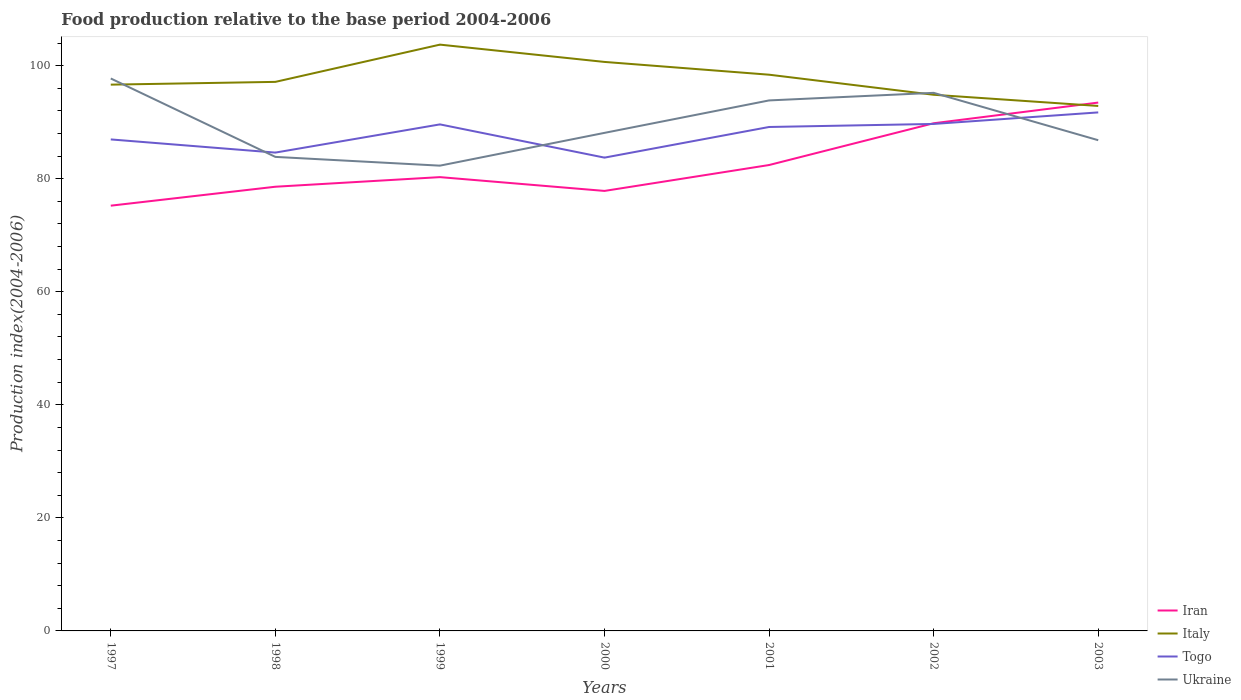How many different coloured lines are there?
Offer a terse response. 4. Does the line corresponding to Italy intersect with the line corresponding to Togo?
Offer a very short reply. No. Across all years, what is the maximum food production index in Ukraine?
Your response must be concise. 82.31. In which year was the food production index in Iran maximum?
Give a very brief answer. 1997. What is the total food production index in Togo in the graph?
Give a very brief answer. -5.42. What is the difference between the highest and the second highest food production index in Italy?
Offer a very short reply. 10.85. How many lines are there?
Keep it short and to the point. 4. How many years are there in the graph?
Your answer should be very brief. 7. What is the difference between two consecutive major ticks on the Y-axis?
Offer a terse response. 20. Does the graph contain grids?
Give a very brief answer. No. Where does the legend appear in the graph?
Keep it short and to the point. Bottom right. What is the title of the graph?
Your answer should be compact. Food production relative to the base period 2004-2006. Does "Central Europe" appear as one of the legend labels in the graph?
Make the answer very short. No. What is the label or title of the X-axis?
Provide a succinct answer. Years. What is the label or title of the Y-axis?
Offer a terse response. Production index(2004-2006). What is the Production index(2004-2006) of Iran in 1997?
Keep it short and to the point. 75.23. What is the Production index(2004-2006) in Italy in 1997?
Provide a succinct answer. 96.64. What is the Production index(2004-2006) of Togo in 1997?
Offer a very short reply. 86.95. What is the Production index(2004-2006) in Ukraine in 1997?
Your answer should be compact. 97.73. What is the Production index(2004-2006) of Iran in 1998?
Offer a terse response. 78.58. What is the Production index(2004-2006) of Italy in 1998?
Provide a succinct answer. 97.13. What is the Production index(2004-2006) in Togo in 1998?
Your response must be concise. 84.62. What is the Production index(2004-2006) of Ukraine in 1998?
Your answer should be very brief. 83.86. What is the Production index(2004-2006) in Iran in 1999?
Provide a short and direct response. 80.28. What is the Production index(2004-2006) in Italy in 1999?
Make the answer very short. 103.72. What is the Production index(2004-2006) in Togo in 1999?
Make the answer very short. 89.61. What is the Production index(2004-2006) in Ukraine in 1999?
Your response must be concise. 82.31. What is the Production index(2004-2006) in Iran in 2000?
Keep it short and to the point. 77.84. What is the Production index(2004-2006) of Italy in 2000?
Give a very brief answer. 100.66. What is the Production index(2004-2006) in Togo in 2000?
Keep it short and to the point. 83.73. What is the Production index(2004-2006) of Ukraine in 2000?
Give a very brief answer. 88.11. What is the Production index(2004-2006) in Iran in 2001?
Provide a succinct answer. 82.42. What is the Production index(2004-2006) in Italy in 2001?
Keep it short and to the point. 98.4. What is the Production index(2004-2006) of Togo in 2001?
Keep it short and to the point. 89.15. What is the Production index(2004-2006) of Ukraine in 2001?
Make the answer very short. 93.85. What is the Production index(2004-2006) of Iran in 2002?
Your answer should be compact. 89.81. What is the Production index(2004-2006) of Italy in 2002?
Offer a terse response. 94.85. What is the Production index(2004-2006) of Togo in 2002?
Your answer should be very brief. 89.69. What is the Production index(2004-2006) of Ukraine in 2002?
Provide a succinct answer. 95.19. What is the Production index(2004-2006) of Iran in 2003?
Make the answer very short. 93.47. What is the Production index(2004-2006) of Italy in 2003?
Make the answer very short. 92.87. What is the Production index(2004-2006) of Togo in 2003?
Offer a very short reply. 91.73. What is the Production index(2004-2006) in Ukraine in 2003?
Offer a very short reply. 86.81. Across all years, what is the maximum Production index(2004-2006) in Iran?
Give a very brief answer. 93.47. Across all years, what is the maximum Production index(2004-2006) of Italy?
Offer a very short reply. 103.72. Across all years, what is the maximum Production index(2004-2006) in Togo?
Your answer should be compact. 91.73. Across all years, what is the maximum Production index(2004-2006) in Ukraine?
Provide a succinct answer. 97.73. Across all years, what is the minimum Production index(2004-2006) in Iran?
Your answer should be compact. 75.23. Across all years, what is the minimum Production index(2004-2006) of Italy?
Ensure brevity in your answer.  92.87. Across all years, what is the minimum Production index(2004-2006) in Togo?
Give a very brief answer. 83.73. Across all years, what is the minimum Production index(2004-2006) of Ukraine?
Keep it short and to the point. 82.31. What is the total Production index(2004-2006) of Iran in the graph?
Your response must be concise. 577.63. What is the total Production index(2004-2006) in Italy in the graph?
Provide a short and direct response. 684.27. What is the total Production index(2004-2006) in Togo in the graph?
Offer a terse response. 615.48. What is the total Production index(2004-2006) of Ukraine in the graph?
Give a very brief answer. 627.86. What is the difference between the Production index(2004-2006) in Iran in 1997 and that in 1998?
Provide a short and direct response. -3.35. What is the difference between the Production index(2004-2006) in Italy in 1997 and that in 1998?
Your response must be concise. -0.49. What is the difference between the Production index(2004-2006) in Togo in 1997 and that in 1998?
Ensure brevity in your answer.  2.33. What is the difference between the Production index(2004-2006) in Ukraine in 1997 and that in 1998?
Keep it short and to the point. 13.87. What is the difference between the Production index(2004-2006) in Iran in 1997 and that in 1999?
Ensure brevity in your answer.  -5.05. What is the difference between the Production index(2004-2006) in Italy in 1997 and that in 1999?
Provide a succinct answer. -7.08. What is the difference between the Production index(2004-2006) of Togo in 1997 and that in 1999?
Offer a terse response. -2.66. What is the difference between the Production index(2004-2006) in Ukraine in 1997 and that in 1999?
Provide a short and direct response. 15.42. What is the difference between the Production index(2004-2006) in Iran in 1997 and that in 2000?
Your answer should be very brief. -2.61. What is the difference between the Production index(2004-2006) in Italy in 1997 and that in 2000?
Your answer should be very brief. -4.02. What is the difference between the Production index(2004-2006) of Togo in 1997 and that in 2000?
Offer a terse response. 3.22. What is the difference between the Production index(2004-2006) in Ukraine in 1997 and that in 2000?
Offer a terse response. 9.62. What is the difference between the Production index(2004-2006) in Iran in 1997 and that in 2001?
Make the answer very short. -7.19. What is the difference between the Production index(2004-2006) of Italy in 1997 and that in 2001?
Provide a short and direct response. -1.76. What is the difference between the Production index(2004-2006) of Ukraine in 1997 and that in 2001?
Offer a very short reply. 3.88. What is the difference between the Production index(2004-2006) of Iran in 1997 and that in 2002?
Make the answer very short. -14.58. What is the difference between the Production index(2004-2006) of Italy in 1997 and that in 2002?
Your response must be concise. 1.79. What is the difference between the Production index(2004-2006) in Togo in 1997 and that in 2002?
Offer a terse response. -2.74. What is the difference between the Production index(2004-2006) in Ukraine in 1997 and that in 2002?
Make the answer very short. 2.54. What is the difference between the Production index(2004-2006) of Iran in 1997 and that in 2003?
Make the answer very short. -18.24. What is the difference between the Production index(2004-2006) in Italy in 1997 and that in 2003?
Give a very brief answer. 3.77. What is the difference between the Production index(2004-2006) of Togo in 1997 and that in 2003?
Ensure brevity in your answer.  -4.78. What is the difference between the Production index(2004-2006) of Ukraine in 1997 and that in 2003?
Offer a very short reply. 10.92. What is the difference between the Production index(2004-2006) in Italy in 1998 and that in 1999?
Your response must be concise. -6.59. What is the difference between the Production index(2004-2006) of Togo in 1998 and that in 1999?
Provide a succinct answer. -4.99. What is the difference between the Production index(2004-2006) of Ukraine in 1998 and that in 1999?
Ensure brevity in your answer.  1.55. What is the difference between the Production index(2004-2006) in Iran in 1998 and that in 2000?
Provide a succinct answer. 0.74. What is the difference between the Production index(2004-2006) in Italy in 1998 and that in 2000?
Your answer should be compact. -3.53. What is the difference between the Production index(2004-2006) of Togo in 1998 and that in 2000?
Provide a short and direct response. 0.89. What is the difference between the Production index(2004-2006) in Ukraine in 1998 and that in 2000?
Your answer should be compact. -4.25. What is the difference between the Production index(2004-2006) of Iran in 1998 and that in 2001?
Provide a succinct answer. -3.84. What is the difference between the Production index(2004-2006) in Italy in 1998 and that in 2001?
Offer a very short reply. -1.27. What is the difference between the Production index(2004-2006) of Togo in 1998 and that in 2001?
Give a very brief answer. -4.53. What is the difference between the Production index(2004-2006) in Ukraine in 1998 and that in 2001?
Offer a terse response. -9.99. What is the difference between the Production index(2004-2006) of Iran in 1998 and that in 2002?
Provide a short and direct response. -11.23. What is the difference between the Production index(2004-2006) of Italy in 1998 and that in 2002?
Make the answer very short. 2.28. What is the difference between the Production index(2004-2006) in Togo in 1998 and that in 2002?
Ensure brevity in your answer.  -5.07. What is the difference between the Production index(2004-2006) of Ukraine in 1998 and that in 2002?
Give a very brief answer. -11.33. What is the difference between the Production index(2004-2006) of Iran in 1998 and that in 2003?
Provide a succinct answer. -14.89. What is the difference between the Production index(2004-2006) in Italy in 1998 and that in 2003?
Your answer should be compact. 4.26. What is the difference between the Production index(2004-2006) in Togo in 1998 and that in 2003?
Your answer should be very brief. -7.11. What is the difference between the Production index(2004-2006) in Ukraine in 1998 and that in 2003?
Your answer should be compact. -2.95. What is the difference between the Production index(2004-2006) of Iran in 1999 and that in 2000?
Your response must be concise. 2.44. What is the difference between the Production index(2004-2006) of Italy in 1999 and that in 2000?
Offer a terse response. 3.06. What is the difference between the Production index(2004-2006) in Togo in 1999 and that in 2000?
Provide a succinct answer. 5.88. What is the difference between the Production index(2004-2006) in Ukraine in 1999 and that in 2000?
Provide a succinct answer. -5.8. What is the difference between the Production index(2004-2006) of Iran in 1999 and that in 2001?
Your response must be concise. -2.14. What is the difference between the Production index(2004-2006) in Italy in 1999 and that in 2001?
Offer a terse response. 5.32. What is the difference between the Production index(2004-2006) in Togo in 1999 and that in 2001?
Offer a terse response. 0.46. What is the difference between the Production index(2004-2006) of Ukraine in 1999 and that in 2001?
Your answer should be very brief. -11.54. What is the difference between the Production index(2004-2006) in Iran in 1999 and that in 2002?
Your answer should be very brief. -9.53. What is the difference between the Production index(2004-2006) of Italy in 1999 and that in 2002?
Your response must be concise. 8.87. What is the difference between the Production index(2004-2006) of Togo in 1999 and that in 2002?
Offer a terse response. -0.08. What is the difference between the Production index(2004-2006) in Ukraine in 1999 and that in 2002?
Provide a short and direct response. -12.88. What is the difference between the Production index(2004-2006) in Iran in 1999 and that in 2003?
Make the answer very short. -13.19. What is the difference between the Production index(2004-2006) of Italy in 1999 and that in 2003?
Your response must be concise. 10.85. What is the difference between the Production index(2004-2006) in Togo in 1999 and that in 2003?
Give a very brief answer. -2.12. What is the difference between the Production index(2004-2006) in Ukraine in 1999 and that in 2003?
Offer a terse response. -4.5. What is the difference between the Production index(2004-2006) in Iran in 2000 and that in 2001?
Your answer should be very brief. -4.58. What is the difference between the Production index(2004-2006) of Italy in 2000 and that in 2001?
Provide a short and direct response. 2.26. What is the difference between the Production index(2004-2006) in Togo in 2000 and that in 2001?
Your answer should be compact. -5.42. What is the difference between the Production index(2004-2006) of Ukraine in 2000 and that in 2001?
Your answer should be compact. -5.74. What is the difference between the Production index(2004-2006) in Iran in 2000 and that in 2002?
Give a very brief answer. -11.97. What is the difference between the Production index(2004-2006) in Italy in 2000 and that in 2002?
Your answer should be very brief. 5.81. What is the difference between the Production index(2004-2006) of Togo in 2000 and that in 2002?
Your response must be concise. -5.96. What is the difference between the Production index(2004-2006) in Ukraine in 2000 and that in 2002?
Make the answer very short. -7.08. What is the difference between the Production index(2004-2006) of Iran in 2000 and that in 2003?
Ensure brevity in your answer.  -15.63. What is the difference between the Production index(2004-2006) in Italy in 2000 and that in 2003?
Offer a terse response. 7.79. What is the difference between the Production index(2004-2006) of Togo in 2000 and that in 2003?
Your answer should be very brief. -8. What is the difference between the Production index(2004-2006) in Ukraine in 2000 and that in 2003?
Provide a short and direct response. 1.3. What is the difference between the Production index(2004-2006) of Iran in 2001 and that in 2002?
Provide a short and direct response. -7.39. What is the difference between the Production index(2004-2006) of Italy in 2001 and that in 2002?
Your response must be concise. 3.55. What is the difference between the Production index(2004-2006) of Togo in 2001 and that in 2002?
Ensure brevity in your answer.  -0.54. What is the difference between the Production index(2004-2006) of Ukraine in 2001 and that in 2002?
Your answer should be very brief. -1.34. What is the difference between the Production index(2004-2006) in Iran in 2001 and that in 2003?
Offer a terse response. -11.05. What is the difference between the Production index(2004-2006) in Italy in 2001 and that in 2003?
Give a very brief answer. 5.53. What is the difference between the Production index(2004-2006) in Togo in 2001 and that in 2003?
Provide a succinct answer. -2.58. What is the difference between the Production index(2004-2006) in Ukraine in 2001 and that in 2003?
Give a very brief answer. 7.04. What is the difference between the Production index(2004-2006) in Iran in 2002 and that in 2003?
Provide a short and direct response. -3.66. What is the difference between the Production index(2004-2006) in Italy in 2002 and that in 2003?
Keep it short and to the point. 1.98. What is the difference between the Production index(2004-2006) in Togo in 2002 and that in 2003?
Make the answer very short. -2.04. What is the difference between the Production index(2004-2006) of Ukraine in 2002 and that in 2003?
Ensure brevity in your answer.  8.38. What is the difference between the Production index(2004-2006) in Iran in 1997 and the Production index(2004-2006) in Italy in 1998?
Your response must be concise. -21.9. What is the difference between the Production index(2004-2006) in Iran in 1997 and the Production index(2004-2006) in Togo in 1998?
Keep it short and to the point. -9.39. What is the difference between the Production index(2004-2006) in Iran in 1997 and the Production index(2004-2006) in Ukraine in 1998?
Provide a succinct answer. -8.63. What is the difference between the Production index(2004-2006) of Italy in 1997 and the Production index(2004-2006) of Togo in 1998?
Provide a short and direct response. 12.02. What is the difference between the Production index(2004-2006) in Italy in 1997 and the Production index(2004-2006) in Ukraine in 1998?
Your response must be concise. 12.78. What is the difference between the Production index(2004-2006) in Togo in 1997 and the Production index(2004-2006) in Ukraine in 1998?
Your answer should be compact. 3.09. What is the difference between the Production index(2004-2006) in Iran in 1997 and the Production index(2004-2006) in Italy in 1999?
Provide a succinct answer. -28.49. What is the difference between the Production index(2004-2006) in Iran in 1997 and the Production index(2004-2006) in Togo in 1999?
Your response must be concise. -14.38. What is the difference between the Production index(2004-2006) in Iran in 1997 and the Production index(2004-2006) in Ukraine in 1999?
Provide a succinct answer. -7.08. What is the difference between the Production index(2004-2006) in Italy in 1997 and the Production index(2004-2006) in Togo in 1999?
Offer a terse response. 7.03. What is the difference between the Production index(2004-2006) in Italy in 1997 and the Production index(2004-2006) in Ukraine in 1999?
Your response must be concise. 14.33. What is the difference between the Production index(2004-2006) of Togo in 1997 and the Production index(2004-2006) of Ukraine in 1999?
Keep it short and to the point. 4.64. What is the difference between the Production index(2004-2006) of Iran in 1997 and the Production index(2004-2006) of Italy in 2000?
Offer a terse response. -25.43. What is the difference between the Production index(2004-2006) of Iran in 1997 and the Production index(2004-2006) of Togo in 2000?
Ensure brevity in your answer.  -8.5. What is the difference between the Production index(2004-2006) in Iran in 1997 and the Production index(2004-2006) in Ukraine in 2000?
Offer a very short reply. -12.88. What is the difference between the Production index(2004-2006) of Italy in 1997 and the Production index(2004-2006) of Togo in 2000?
Give a very brief answer. 12.91. What is the difference between the Production index(2004-2006) in Italy in 1997 and the Production index(2004-2006) in Ukraine in 2000?
Your answer should be compact. 8.53. What is the difference between the Production index(2004-2006) in Togo in 1997 and the Production index(2004-2006) in Ukraine in 2000?
Offer a terse response. -1.16. What is the difference between the Production index(2004-2006) in Iran in 1997 and the Production index(2004-2006) in Italy in 2001?
Provide a succinct answer. -23.17. What is the difference between the Production index(2004-2006) of Iran in 1997 and the Production index(2004-2006) of Togo in 2001?
Make the answer very short. -13.92. What is the difference between the Production index(2004-2006) in Iran in 1997 and the Production index(2004-2006) in Ukraine in 2001?
Your response must be concise. -18.62. What is the difference between the Production index(2004-2006) in Italy in 1997 and the Production index(2004-2006) in Togo in 2001?
Give a very brief answer. 7.49. What is the difference between the Production index(2004-2006) of Italy in 1997 and the Production index(2004-2006) of Ukraine in 2001?
Your response must be concise. 2.79. What is the difference between the Production index(2004-2006) of Iran in 1997 and the Production index(2004-2006) of Italy in 2002?
Your answer should be very brief. -19.62. What is the difference between the Production index(2004-2006) of Iran in 1997 and the Production index(2004-2006) of Togo in 2002?
Make the answer very short. -14.46. What is the difference between the Production index(2004-2006) in Iran in 1997 and the Production index(2004-2006) in Ukraine in 2002?
Make the answer very short. -19.96. What is the difference between the Production index(2004-2006) of Italy in 1997 and the Production index(2004-2006) of Togo in 2002?
Your answer should be compact. 6.95. What is the difference between the Production index(2004-2006) of Italy in 1997 and the Production index(2004-2006) of Ukraine in 2002?
Your answer should be very brief. 1.45. What is the difference between the Production index(2004-2006) of Togo in 1997 and the Production index(2004-2006) of Ukraine in 2002?
Your answer should be compact. -8.24. What is the difference between the Production index(2004-2006) in Iran in 1997 and the Production index(2004-2006) in Italy in 2003?
Give a very brief answer. -17.64. What is the difference between the Production index(2004-2006) in Iran in 1997 and the Production index(2004-2006) in Togo in 2003?
Provide a succinct answer. -16.5. What is the difference between the Production index(2004-2006) of Iran in 1997 and the Production index(2004-2006) of Ukraine in 2003?
Offer a terse response. -11.58. What is the difference between the Production index(2004-2006) of Italy in 1997 and the Production index(2004-2006) of Togo in 2003?
Your response must be concise. 4.91. What is the difference between the Production index(2004-2006) of Italy in 1997 and the Production index(2004-2006) of Ukraine in 2003?
Your response must be concise. 9.83. What is the difference between the Production index(2004-2006) in Togo in 1997 and the Production index(2004-2006) in Ukraine in 2003?
Provide a short and direct response. 0.14. What is the difference between the Production index(2004-2006) in Iran in 1998 and the Production index(2004-2006) in Italy in 1999?
Give a very brief answer. -25.14. What is the difference between the Production index(2004-2006) of Iran in 1998 and the Production index(2004-2006) of Togo in 1999?
Provide a short and direct response. -11.03. What is the difference between the Production index(2004-2006) of Iran in 1998 and the Production index(2004-2006) of Ukraine in 1999?
Offer a terse response. -3.73. What is the difference between the Production index(2004-2006) in Italy in 1998 and the Production index(2004-2006) in Togo in 1999?
Give a very brief answer. 7.52. What is the difference between the Production index(2004-2006) of Italy in 1998 and the Production index(2004-2006) of Ukraine in 1999?
Your answer should be compact. 14.82. What is the difference between the Production index(2004-2006) of Togo in 1998 and the Production index(2004-2006) of Ukraine in 1999?
Provide a succinct answer. 2.31. What is the difference between the Production index(2004-2006) of Iran in 1998 and the Production index(2004-2006) of Italy in 2000?
Keep it short and to the point. -22.08. What is the difference between the Production index(2004-2006) in Iran in 1998 and the Production index(2004-2006) in Togo in 2000?
Make the answer very short. -5.15. What is the difference between the Production index(2004-2006) in Iran in 1998 and the Production index(2004-2006) in Ukraine in 2000?
Your response must be concise. -9.53. What is the difference between the Production index(2004-2006) of Italy in 1998 and the Production index(2004-2006) of Ukraine in 2000?
Provide a short and direct response. 9.02. What is the difference between the Production index(2004-2006) of Togo in 1998 and the Production index(2004-2006) of Ukraine in 2000?
Provide a short and direct response. -3.49. What is the difference between the Production index(2004-2006) of Iran in 1998 and the Production index(2004-2006) of Italy in 2001?
Give a very brief answer. -19.82. What is the difference between the Production index(2004-2006) in Iran in 1998 and the Production index(2004-2006) in Togo in 2001?
Your answer should be compact. -10.57. What is the difference between the Production index(2004-2006) of Iran in 1998 and the Production index(2004-2006) of Ukraine in 2001?
Ensure brevity in your answer.  -15.27. What is the difference between the Production index(2004-2006) in Italy in 1998 and the Production index(2004-2006) in Togo in 2001?
Make the answer very short. 7.98. What is the difference between the Production index(2004-2006) of Italy in 1998 and the Production index(2004-2006) of Ukraine in 2001?
Ensure brevity in your answer.  3.28. What is the difference between the Production index(2004-2006) in Togo in 1998 and the Production index(2004-2006) in Ukraine in 2001?
Your answer should be compact. -9.23. What is the difference between the Production index(2004-2006) of Iran in 1998 and the Production index(2004-2006) of Italy in 2002?
Keep it short and to the point. -16.27. What is the difference between the Production index(2004-2006) in Iran in 1998 and the Production index(2004-2006) in Togo in 2002?
Give a very brief answer. -11.11. What is the difference between the Production index(2004-2006) of Iran in 1998 and the Production index(2004-2006) of Ukraine in 2002?
Give a very brief answer. -16.61. What is the difference between the Production index(2004-2006) in Italy in 1998 and the Production index(2004-2006) in Togo in 2002?
Offer a terse response. 7.44. What is the difference between the Production index(2004-2006) of Italy in 1998 and the Production index(2004-2006) of Ukraine in 2002?
Offer a terse response. 1.94. What is the difference between the Production index(2004-2006) of Togo in 1998 and the Production index(2004-2006) of Ukraine in 2002?
Offer a terse response. -10.57. What is the difference between the Production index(2004-2006) in Iran in 1998 and the Production index(2004-2006) in Italy in 2003?
Offer a terse response. -14.29. What is the difference between the Production index(2004-2006) in Iran in 1998 and the Production index(2004-2006) in Togo in 2003?
Provide a short and direct response. -13.15. What is the difference between the Production index(2004-2006) of Iran in 1998 and the Production index(2004-2006) of Ukraine in 2003?
Your response must be concise. -8.23. What is the difference between the Production index(2004-2006) in Italy in 1998 and the Production index(2004-2006) in Ukraine in 2003?
Give a very brief answer. 10.32. What is the difference between the Production index(2004-2006) of Togo in 1998 and the Production index(2004-2006) of Ukraine in 2003?
Give a very brief answer. -2.19. What is the difference between the Production index(2004-2006) of Iran in 1999 and the Production index(2004-2006) of Italy in 2000?
Ensure brevity in your answer.  -20.38. What is the difference between the Production index(2004-2006) of Iran in 1999 and the Production index(2004-2006) of Togo in 2000?
Provide a short and direct response. -3.45. What is the difference between the Production index(2004-2006) of Iran in 1999 and the Production index(2004-2006) of Ukraine in 2000?
Your response must be concise. -7.83. What is the difference between the Production index(2004-2006) of Italy in 1999 and the Production index(2004-2006) of Togo in 2000?
Provide a short and direct response. 19.99. What is the difference between the Production index(2004-2006) in Italy in 1999 and the Production index(2004-2006) in Ukraine in 2000?
Ensure brevity in your answer.  15.61. What is the difference between the Production index(2004-2006) in Togo in 1999 and the Production index(2004-2006) in Ukraine in 2000?
Give a very brief answer. 1.5. What is the difference between the Production index(2004-2006) of Iran in 1999 and the Production index(2004-2006) of Italy in 2001?
Keep it short and to the point. -18.12. What is the difference between the Production index(2004-2006) of Iran in 1999 and the Production index(2004-2006) of Togo in 2001?
Ensure brevity in your answer.  -8.87. What is the difference between the Production index(2004-2006) of Iran in 1999 and the Production index(2004-2006) of Ukraine in 2001?
Provide a short and direct response. -13.57. What is the difference between the Production index(2004-2006) in Italy in 1999 and the Production index(2004-2006) in Togo in 2001?
Provide a short and direct response. 14.57. What is the difference between the Production index(2004-2006) in Italy in 1999 and the Production index(2004-2006) in Ukraine in 2001?
Provide a short and direct response. 9.87. What is the difference between the Production index(2004-2006) in Togo in 1999 and the Production index(2004-2006) in Ukraine in 2001?
Offer a terse response. -4.24. What is the difference between the Production index(2004-2006) in Iran in 1999 and the Production index(2004-2006) in Italy in 2002?
Your answer should be very brief. -14.57. What is the difference between the Production index(2004-2006) of Iran in 1999 and the Production index(2004-2006) of Togo in 2002?
Make the answer very short. -9.41. What is the difference between the Production index(2004-2006) in Iran in 1999 and the Production index(2004-2006) in Ukraine in 2002?
Offer a very short reply. -14.91. What is the difference between the Production index(2004-2006) of Italy in 1999 and the Production index(2004-2006) of Togo in 2002?
Give a very brief answer. 14.03. What is the difference between the Production index(2004-2006) in Italy in 1999 and the Production index(2004-2006) in Ukraine in 2002?
Keep it short and to the point. 8.53. What is the difference between the Production index(2004-2006) in Togo in 1999 and the Production index(2004-2006) in Ukraine in 2002?
Provide a succinct answer. -5.58. What is the difference between the Production index(2004-2006) of Iran in 1999 and the Production index(2004-2006) of Italy in 2003?
Provide a succinct answer. -12.59. What is the difference between the Production index(2004-2006) of Iran in 1999 and the Production index(2004-2006) of Togo in 2003?
Give a very brief answer. -11.45. What is the difference between the Production index(2004-2006) of Iran in 1999 and the Production index(2004-2006) of Ukraine in 2003?
Make the answer very short. -6.53. What is the difference between the Production index(2004-2006) of Italy in 1999 and the Production index(2004-2006) of Togo in 2003?
Your answer should be compact. 11.99. What is the difference between the Production index(2004-2006) in Italy in 1999 and the Production index(2004-2006) in Ukraine in 2003?
Offer a terse response. 16.91. What is the difference between the Production index(2004-2006) in Iran in 2000 and the Production index(2004-2006) in Italy in 2001?
Your answer should be very brief. -20.56. What is the difference between the Production index(2004-2006) in Iran in 2000 and the Production index(2004-2006) in Togo in 2001?
Make the answer very short. -11.31. What is the difference between the Production index(2004-2006) in Iran in 2000 and the Production index(2004-2006) in Ukraine in 2001?
Your response must be concise. -16.01. What is the difference between the Production index(2004-2006) of Italy in 2000 and the Production index(2004-2006) of Togo in 2001?
Ensure brevity in your answer.  11.51. What is the difference between the Production index(2004-2006) in Italy in 2000 and the Production index(2004-2006) in Ukraine in 2001?
Give a very brief answer. 6.81. What is the difference between the Production index(2004-2006) of Togo in 2000 and the Production index(2004-2006) of Ukraine in 2001?
Keep it short and to the point. -10.12. What is the difference between the Production index(2004-2006) in Iran in 2000 and the Production index(2004-2006) in Italy in 2002?
Give a very brief answer. -17.01. What is the difference between the Production index(2004-2006) in Iran in 2000 and the Production index(2004-2006) in Togo in 2002?
Provide a short and direct response. -11.85. What is the difference between the Production index(2004-2006) of Iran in 2000 and the Production index(2004-2006) of Ukraine in 2002?
Provide a short and direct response. -17.35. What is the difference between the Production index(2004-2006) in Italy in 2000 and the Production index(2004-2006) in Togo in 2002?
Give a very brief answer. 10.97. What is the difference between the Production index(2004-2006) of Italy in 2000 and the Production index(2004-2006) of Ukraine in 2002?
Offer a very short reply. 5.47. What is the difference between the Production index(2004-2006) of Togo in 2000 and the Production index(2004-2006) of Ukraine in 2002?
Offer a terse response. -11.46. What is the difference between the Production index(2004-2006) of Iran in 2000 and the Production index(2004-2006) of Italy in 2003?
Ensure brevity in your answer.  -15.03. What is the difference between the Production index(2004-2006) in Iran in 2000 and the Production index(2004-2006) in Togo in 2003?
Offer a very short reply. -13.89. What is the difference between the Production index(2004-2006) in Iran in 2000 and the Production index(2004-2006) in Ukraine in 2003?
Your answer should be compact. -8.97. What is the difference between the Production index(2004-2006) of Italy in 2000 and the Production index(2004-2006) of Togo in 2003?
Keep it short and to the point. 8.93. What is the difference between the Production index(2004-2006) in Italy in 2000 and the Production index(2004-2006) in Ukraine in 2003?
Make the answer very short. 13.85. What is the difference between the Production index(2004-2006) of Togo in 2000 and the Production index(2004-2006) of Ukraine in 2003?
Your response must be concise. -3.08. What is the difference between the Production index(2004-2006) in Iran in 2001 and the Production index(2004-2006) in Italy in 2002?
Give a very brief answer. -12.43. What is the difference between the Production index(2004-2006) of Iran in 2001 and the Production index(2004-2006) of Togo in 2002?
Offer a very short reply. -7.27. What is the difference between the Production index(2004-2006) in Iran in 2001 and the Production index(2004-2006) in Ukraine in 2002?
Provide a succinct answer. -12.77. What is the difference between the Production index(2004-2006) in Italy in 2001 and the Production index(2004-2006) in Togo in 2002?
Provide a short and direct response. 8.71. What is the difference between the Production index(2004-2006) in Italy in 2001 and the Production index(2004-2006) in Ukraine in 2002?
Provide a short and direct response. 3.21. What is the difference between the Production index(2004-2006) of Togo in 2001 and the Production index(2004-2006) of Ukraine in 2002?
Your answer should be very brief. -6.04. What is the difference between the Production index(2004-2006) in Iran in 2001 and the Production index(2004-2006) in Italy in 2003?
Your answer should be compact. -10.45. What is the difference between the Production index(2004-2006) of Iran in 2001 and the Production index(2004-2006) of Togo in 2003?
Offer a very short reply. -9.31. What is the difference between the Production index(2004-2006) of Iran in 2001 and the Production index(2004-2006) of Ukraine in 2003?
Keep it short and to the point. -4.39. What is the difference between the Production index(2004-2006) in Italy in 2001 and the Production index(2004-2006) in Togo in 2003?
Ensure brevity in your answer.  6.67. What is the difference between the Production index(2004-2006) in Italy in 2001 and the Production index(2004-2006) in Ukraine in 2003?
Your answer should be very brief. 11.59. What is the difference between the Production index(2004-2006) of Togo in 2001 and the Production index(2004-2006) of Ukraine in 2003?
Your response must be concise. 2.34. What is the difference between the Production index(2004-2006) of Iran in 2002 and the Production index(2004-2006) of Italy in 2003?
Your response must be concise. -3.06. What is the difference between the Production index(2004-2006) of Iran in 2002 and the Production index(2004-2006) of Togo in 2003?
Your response must be concise. -1.92. What is the difference between the Production index(2004-2006) of Iran in 2002 and the Production index(2004-2006) of Ukraine in 2003?
Keep it short and to the point. 3. What is the difference between the Production index(2004-2006) in Italy in 2002 and the Production index(2004-2006) in Togo in 2003?
Your answer should be very brief. 3.12. What is the difference between the Production index(2004-2006) in Italy in 2002 and the Production index(2004-2006) in Ukraine in 2003?
Provide a short and direct response. 8.04. What is the difference between the Production index(2004-2006) in Togo in 2002 and the Production index(2004-2006) in Ukraine in 2003?
Provide a short and direct response. 2.88. What is the average Production index(2004-2006) of Iran per year?
Provide a succinct answer. 82.52. What is the average Production index(2004-2006) of Italy per year?
Provide a short and direct response. 97.75. What is the average Production index(2004-2006) in Togo per year?
Your answer should be compact. 87.93. What is the average Production index(2004-2006) of Ukraine per year?
Offer a very short reply. 89.69. In the year 1997, what is the difference between the Production index(2004-2006) in Iran and Production index(2004-2006) in Italy?
Provide a succinct answer. -21.41. In the year 1997, what is the difference between the Production index(2004-2006) of Iran and Production index(2004-2006) of Togo?
Ensure brevity in your answer.  -11.72. In the year 1997, what is the difference between the Production index(2004-2006) in Iran and Production index(2004-2006) in Ukraine?
Your answer should be very brief. -22.5. In the year 1997, what is the difference between the Production index(2004-2006) of Italy and Production index(2004-2006) of Togo?
Make the answer very short. 9.69. In the year 1997, what is the difference between the Production index(2004-2006) of Italy and Production index(2004-2006) of Ukraine?
Keep it short and to the point. -1.09. In the year 1997, what is the difference between the Production index(2004-2006) of Togo and Production index(2004-2006) of Ukraine?
Your answer should be very brief. -10.78. In the year 1998, what is the difference between the Production index(2004-2006) in Iran and Production index(2004-2006) in Italy?
Ensure brevity in your answer.  -18.55. In the year 1998, what is the difference between the Production index(2004-2006) in Iran and Production index(2004-2006) in Togo?
Give a very brief answer. -6.04. In the year 1998, what is the difference between the Production index(2004-2006) of Iran and Production index(2004-2006) of Ukraine?
Offer a very short reply. -5.28. In the year 1998, what is the difference between the Production index(2004-2006) of Italy and Production index(2004-2006) of Togo?
Keep it short and to the point. 12.51. In the year 1998, what is the difference between the Production index(2004-2006) of Italy and Production index(2004-2006) of Ukraine?
Offer a very short reply. 13.27. In the year 1998, what is the difference between the Production index(2004-2006) of Togo and Production index(2004-2006) of Ukraine?
Keep it short and to the point. 0.76. In the year 1999, what is the difference between the Production index(2004-2006) in Iran and Production index(2004-2006) in Italy?
Give a very brief answer. -23.44. In the year 1999, what is the difference between the Production index(2004-2006) of Iran and Production index(2004-2006) of Togo?
Offer a terse response. -9.33. In the year 1999, what is the difference between the Production index(2004-2006) in Iran and Production index(2004-2006) in Ukraine?
Make the answer very short. -2.03. In the year 1999, what is the difference between the Production index(2004-2006) in Italy and Production index(2004-2006) in Togo?
Your response must be concise. 14.11. In the year 1999, what is the difference between the Production index(2004-2006) of Italy and Production index(2004-2006) of Ukraine?
Offer a terse response. 21.41. In the year 1999, what is the difference between the Production index(2004-2006) of Togo and Production index(2004-2006) of Ukraine?
Make the answer very short. 7.3. In the year 2000, what is the difference between the Production index(2004-2006) in Iran and Production index(2004-2006) in Italy?
Your answer should be compact. -22.82. In the year 2000, what is the difference between the Production index(2004-2006) in Iran and Production index(2004-2006) in Togo?
Offer a terse response. -5.89. In the year 2000, what is the difference between the Production index(2004-2006) of Iran and Production index(2004-2006) of Ukraine?
Provide a succinct answer. -10.27. In the year 2000, what is the difference between the Production index(2004-2006) in Italy and Production index(2004-2006) in Togo?
Offer a very short reply. 16.93. In the year 2000, what is the difference between the Production index(2004-2006) of Italy and Production index(2004-2006) of Ukraine?
Provide a succinct answer. 12.55. In the year 2000, what is the difference between the Production index(2004-2006) of Togo and Production index(2004-2006) of Ukraine?
Keep it short and to the point. -4.38. In the year 2001, what is the difference between the Production index(2004-2006) of Iran and Production index(2004-2006) of Italy?
Ensure brevity in your answer.  -15.98. In the year 2001, what is the difference between the Production index(2004-2006) in Iran and Production index(2004-2006) in Togo?
Your response must be concise. -6.73. In the year 2001, what is the difference between the Production index(2004-2006) of Iran and Production index(2004-2006) of Ukraine?
Your answer should be very brief. -11.43. In the year 2001, what is the difference between the Production index(2004-2006) in Italy and Production index(2004-2006) in Togo?
Your answer should be very brief. 9.25. In the year 2001, what is the difference between the Production index(2004-2006) of Italy and Production index(2004-2006) of Ukraine?
Give a very brief answer. 4.55. In the year 2002, what is the difference between the Production index(2004-2006) in Iran and Production index(2004-2006) in Italy?
Your response must be concise. -5.04. In the year 2002, what is the difference between the Production index(2004-2006) in Iran and Production index(2004-2006) in Togo?
Provide a succinct answer. 0.12. In the year 2002, what is the difference between the Production index(2004-2006) of Iran and Production index(2004-2006) of Ukraine?
Your answer should be very brief. -5.38. In the year 2002, what is the difference between the Production index(2004-2006) in Italy and Production index(2004-2006) in Togo?
Ensure brevity in your answer.  5.16. In the year 2002, what is the difference between the Production index(2004-2006) in Italy and Production index(2004-2006) in Ukraine?
Your response must be concise. -0.34. In the year 2003, what is the difference between the Production index(2004-2006) of Iran and Production index(2004-2006) of Togo?
Your response must be concise. 1.74. In the year 2003, what is the difference between the Production index(2004-2006) of Iran and Production index(2004-2006) of Ukraine?
Offer a very short reply. 6.66. In the year 2003, what is the difference between the Production index(2004-2006) in Italy and Production index(2004-2006) in Togo?
Offer a very short reply. 1.14. In the year 2003, what is the difference between the Production index(2004-2006) in Italy and Production index(2004-2006) in Ukraine?
Ensure brevity in your answer.  6.06. In the year 2003, what is the difference between the Production index(2004-2006) of Togo and Production index(2004-2006) of Ukraine?
Your response must be concise. 4.92. What is the ratio of the Production index(2004-2006) in Iran in 1997 to that in 1998?
Give a very brief answer. 0.96. What is the ratio of the Production index(2004-2006) in Italy in 1997 to that in 1998?
Your answer should be compact. 0.99. What is the ratio of the Production index(2004-2006) of Togo in 1997 to that in 1998?
Make the answer very short. 1.03. What is the ratio of the Production index(2004-2006) of Ukraine in 1997 to that in 1998?
Your response must be concise. 1.17. What is the ratio of the Production index(2004-2006) of Iran in 1997 to that in 1999?
Your answer should be compact. 0.94. What is the ratio of the Production index(2004-2006) in Italy in 1997 to that in 1999?
Offer a terse response. 0.93. What is the ratio of the Production index(2004-2006) of Togo in 1997 to that in 1999?
Make the answer very short. 0.97. What is the ratio of the Production index(2004-2006) of Ukraine in 1997 to that in 1999?
Give a very brief answer. 1.19. What is the ratio of the Production index(2004-2006) of Iran in 1997 to that in 2000?
Offer a terse response. 0.97. What is the ratio of the Production index(2004-2006) in Italy in 1997 to that in 2000?
Ensure brevity in your answer.  0.96. What is the ratio of the Production index(2004-2006) in Ukraine in 1997 to that in 2000?
Ensure brevity in your answer.  1.11. What is the ratio of the Production index(2004-2006) in Iran in 1997 to that in 2001?
Give a very brief answer. 0.91. What is the ratio of the Production index(2004-2006) of Italy in 1997 to that in 2001?
Your answer should be very brief. 0.98. What is the ratio of the Production index(2004-2006) in Togo in 1997 to that in 2001?
Offer a very short reply. 0.98. What is the ratio of the Production index(2004-2006) of Ukraine in 1997 to that in 2001?
Your answer should be compact. 1.04. What is the ratio of the Production index(2004-2006) of Iran in 1997 to that in 2002?
Provide a short and direct response. 0.84. What is the ratio of the Production index(2004-2006) of Italy in 1997 to that in 2002?
Give a very brief answer. 1.02. What is the ratio of the Production index(2004-2006) of Togo in 1997 to that in 2002?
Your response must be concise. 0.97. What is the ratio of the Production index(2004-2006) of Ukraine in 1997 to that in 2002?
Ensure brevity in your answer.  1.03. What is the ratio of the Production index(2004-2006) of Iran in 1997 to that in 2003?
Provide a succinct answer. 0.8. What is the ratio of the Production index(2004-2006) in Italy in 1997 to that in 2003?
Offer a very short reply. 1.04. What is the ratio of the Production index(2004-2006) of Togo in 1997 to that in 2003?
Make the answer very short. 0.95. What is the ratio of the Production index(2004-2006) in Ukraine in 1997 to that in 2003?
Keep it short and to the point. 1.13. What is the ratio of the Production index(2004-2006) in Iran in 1998 to that in 1999?
Your answer should be very brief. 0.98. What is the ratio of the Production index(2004-2006) of Italy in 1998 to that in 1999?
Offer a terse response. 0.94. What is the ratio of the Production index(2004-2006) in Togo in 1998 to that in 1999?
Your response must be concise. 0.94. What is the ratio of the Production index(2004-2006) of Ukraine in 1998 to that in 1999?
Provide a succinct answer. 1.02. What is the ratio of the Production index(2004-2006) of Iran in 1998 to that in 2000?
Provide a short and direct response. 1.01. What is the ratio of the Production index(2004-2006) of Italy in 1998 to that in 2000?
Offer a terse response. 0.96. What is the ratio of the Production index(2004-2006) in Togo in 1998 to that in 2000?
Offer a terse response. 1.01. What is the ratio of the Production index(2004-2006) of Ukraine in 1998 to that in 2000?
Ensure brevity in your answer.  0.95. What is the ratio of the Production index(2004-2006) in Iran in 1998 to that in 2001?
Your answer should be compact. 0.95. What is the ratio of the Production index(2004-2006) of Italy in 1998 to that in 2001?
Provide a succinct answer. 0.99. What is the ratio of the Production index(2004-2006) in Togo in 1998 to that in 2001?
Your response must be concise. 0.95. What is the ratio of the Production index(2004-2006) in Ukraine in 1998 to that in 2001?
Give a very brief answer. 0.89. What is the ratio of the Production index(2004-2006) of Italy in 1998 to that in 2002?
Offer a terse response. 1.02. What is the ratio of the Production index(2004-2006) in Togo in 1998 to that in 2002?
Your response must be concise. 0.94. What is the ratio of the Production index(2004-2006) of Ukraine in 1998 to that in 2002?
Give a very brief answer. 0.88. What is the ratio of the Production index(2004-2006) of Iran in 1998 to that in 2003?
Ensure brevity in your answer.  0.84. What is the ratio of the Production index(2004-2006) in Italy in 1998 to that in 2003?
Provide a succinct answer. 1.05. What is the ratio of the Production index(2004-2006) in Togo in 1998 to that in 2003?
Make the answer very short. 0.92. What is the ratio of the Production index(2004-2006) of Ukraine in 1998 to that in 2003?
Keep it short and to the point. 0.97. What is the ratio of the Production index(2004-2006) in Iran in 1999 to that in 2000?
Offer a terse response. 1.03. What is the ratio of the Production index(2004-2006) in Italy in 1999 to that in 2000?
Offer a very short reply. 1.03. What is the ratio of the Production index(2004-2006) in Togo in 1999 to that in 2000?
Your answer should be compact. 1.07. What is the ratio of the Production index(2004-2006) of Ukraine in 1999 to that in 2000?
Make the answer very short. 0.93. What is the ratio of the Production index(2004-2006) of Italy in 1999 to that in 2001?
Your answer should be very brief. 1.05. What is the ratio of the Production index(2004-2006) in Togo in 1999 to that in 2001?
Provide a short and direct response. 1.01. What is the ratio of the Production index(2004-2006) in Ukraine in 1999 to that in 2001?
Make the answer very short. 0.88. What is the ratio of the Production index(2004-2006) of Iran in 1999 to that in 2002?
Provide a succinct answer. 0.89. What is the ratio of the Production index(2004-2006) in Italy in 1999 to that in 2002?
Keep it short and to the point. 1.09. What is the ratio of the Production index(2004-2006) in Togo in 1999 to that in 2002?
Ensure brevity in your answer.  1. What is the ratio of the Production index(2004-2006) in Ukraine in 1999 to that in 2002?
Provide a succinct answer. 0.86. What is the ratio of the Production index(2004-2006) in Iran in 1999 to that in 2003?
Provide a succinct answer. 0.86. What is the ratio of the Production index(2004-2006) of Italy in 1999 to that in 2003?
Give a very brief answer. 1.12. What is the ratio of the Production index(2004-2006) in Togo in 1999 to that in 2003?
Keep it short and to the point. 0.98. What is the ratio of the Production index(2004-2006) in Ukraine in 1999 to that in 2003?
Provide a succinct answer. 0.95. What is the ratio of the Production index(2004-2006) in Italy in 2000 to that in 2001?
Provide a short and direct response. 1.02. What is the ratio of the Production index(2004-2006) of Togo in 2000 to that in 2001?
Provide a succinct answer. 0.94. What is the ratio of the Production index(2004-2006) of Ukraine in 2000 to that in 2001?
Your response must be concise. 0.94. What is the ratio of the Production index(2004-2006) in Iran in 2000 to that in 2002?
Provide a short and direct response. 0.87. What is the ratio of the Production index(2004-2006) of Italy in 2000 to that in 2002?
Offer a very short reply. 1.06. What is the ratio of the Production index(2004-2006) in Togo in 2000 to that in 2002?
Your response must be concise. 0.93. What is the ratio of the Production index(2004-2006) of Ukraine in 2000 to that in 2002?
Ensure brevity in your answer.  0.93. What is the ratio of the Production index(2004-2006) in Iran in 2000 to that in 2003?
Provide a succinct answer. 0.83. What is the ratio of the Production index(2004-2006) in Italy in 2000 to that in 2003?
Give a very brief answer. 1.08. What is the ratio of the Production index(2004-2006) in Togo in 2000 to that in 2003?
Give a very brief answer. 0.91. What is the ratio of the Production index(2004-2006) of Iran in 2001 to that in 2002?
Your answer should be very brief. 0.92. What is the ratio of the Production index(2004-2006) in Italy in 2001 to that in 2002?
Your answer should be very brief. 1.04. What is the ratio of the Production index(2004-2006) in Ukraine in 2001 to that in 2002?
Ensure brevity in your answer.  0.99. What is the ratio of the Production index(2004-2006) of Iran in 2001 to that in 2003?
Provide a short and direct response. 0.88. What is the ratio of the Production index(2004-2006) of Italy in 2001 to that in 2003?
Keep it short and to the point. 1.06. What is the ratio of the Production index(2004-2006) in Togo in 2001 to that in 2003?
Provide a short and direct response. 0.97. What is the ratio of the Production index(2004-2006) of Ukraine in 2001 to that in 2003?
Offer a terse response. 1.08. What is the ratio of the Production index(2004-2006) in Iran in 2002 to that in 2003?
Offer a very short reply. 0.96. What is the ratio of the Production index(2004-2006) in Italy in 2002 to that in 2003?
Offer a terse response. 1.02. What is the ratio of the Production index(2004-2006) of Togo in 2002 to that in 2003?
Your answer should be very brief. 0.98. What is the ratio of the Production index(2004-2006) in Ukraine in 2002 to that in 2003?
Make the answer very short. 1.1. What is the difference between the highest and the second highest Production index(2004-2006) of Iran?
Your response must be concise. 3.66. What is the difference between the highest and the second highest Production index(2004-2006) of Italy?
Ensure brevity in your answer.  3.06. What is the difference between the highest and the second highest Production index(2004-2006) in Togo?
Offer a terse response. 2.04. What is the difference between the highest and the second highest Production index(2004-2006) of Ukraine?
Offer a terse response. 2.54. What is the difference between the highest and the lowest Production index(2004-2006) in Iran?
Make the answer very short. 18.24. What is the difference between the highest and the lowest Production index(2004-2006) of Italy?
Your answer should be compact. 10.85. What is the difference between the highest and the lowest Production index(2004-2006) in Ukraine?
Offer a very short reply. 15.42. 